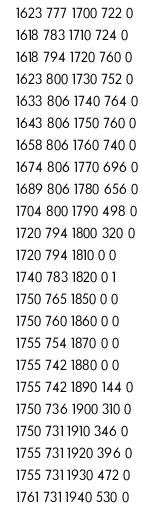Convert code to text. <code><loc_0><loc_0><loc_500><loc_500><_SML_>1623 777 1700 722 0
1618 783 1710 724 0
1618 794 1720 760 0
1623 800 1730 752 0
1633 806 1740 764 0
1643 806 1750 760 0
1658 806 1760 740 0
1674 806 1770 696 0
1689 806 1780 656 0
1704 800 1790 498 0
1720 794 1800 320 0
1720 794 1810 0 0
1740 783 1820 0 1
1750 765 1850 0 0
1750 760 1860 0 0
1755 754 1870 0 0
1755 742 1880 0 0
1755 742 1890 144 0
1750 736 1900 310 0
1750 731 1910 346 0
1755 731 1920 396 0
1755 731 1930 472 0
1761 731 1940 530 0</code> 